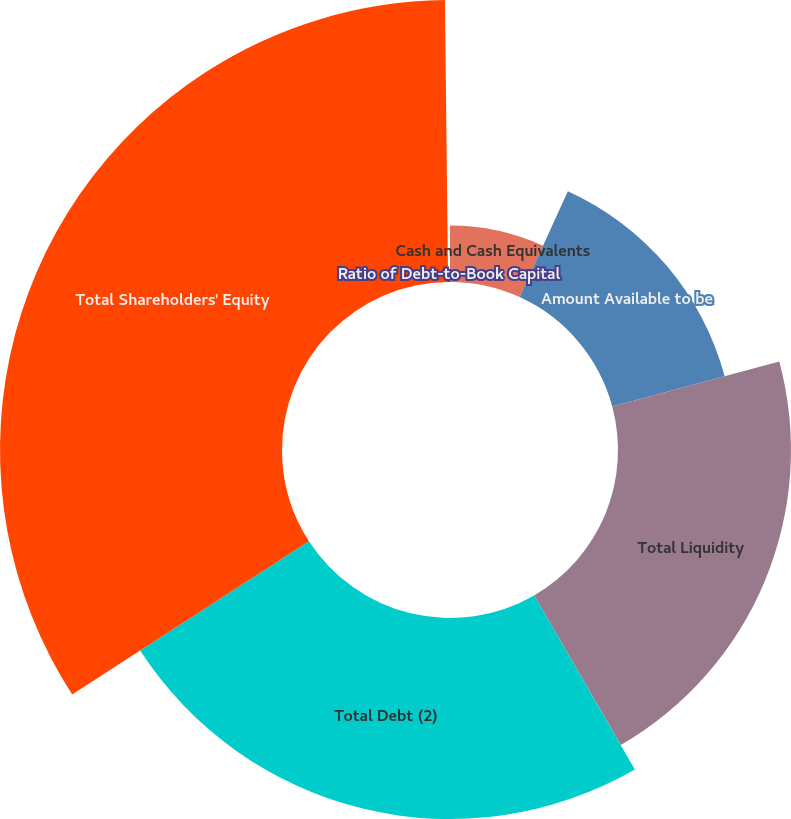Convert chart to OTSL. <chart><loc_0><loc_0><loc_500><loc_500><pie_chart><fcel>Cash and Cash Equivalents<fcel>Amount Available to be<fcel>Total Liquidity<fcel>Total Debt (2)<fcel>Total Shareholders' Equity<fcel>Ratio of Debt-to-Book Capital<nl><fcel>6.8%<fcel>14.02%<fcel>20.83%<fcel>24.21%<fcel>33.96%<fcel>0.18%<nl></chart> 